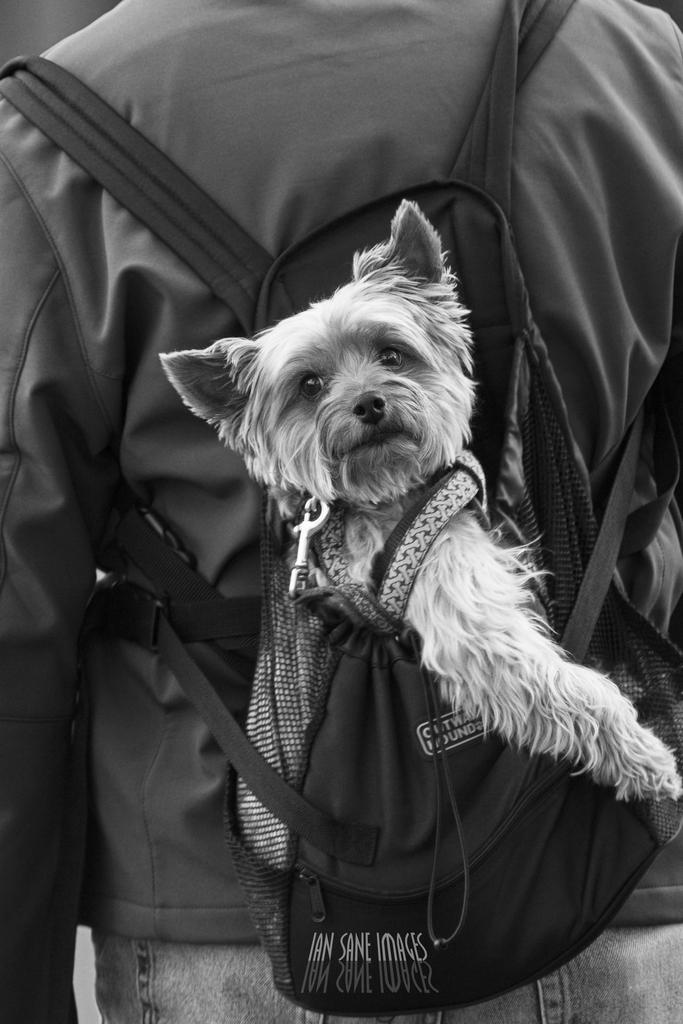What can be seen in the image? There is a person in the image. What is the person wearing? The person is wearing a jacket. What is the person carrying? The person is carrying a backpack. What is inside the backpack? There is a puppy in the backpack. What type of thought can be seen floating above the person's head in the image? There is no thought visible in the image; it only shows a person wearing a jacket, carrying a backpack with a puppy inside. 